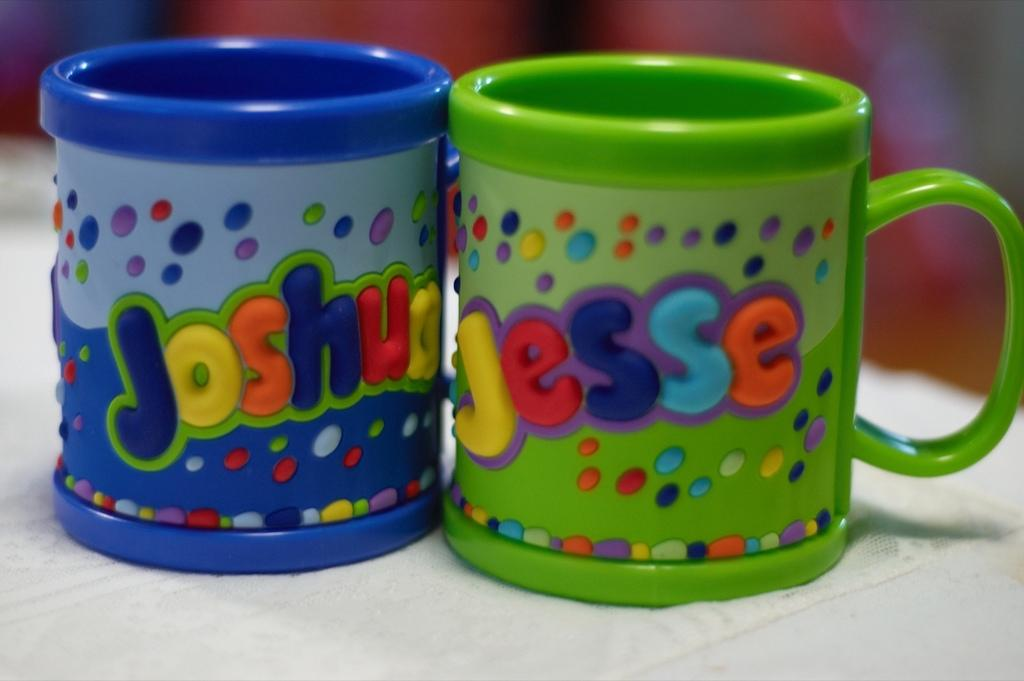<image>
Share a concise interpretation of the image provided. Blue cup that says Joshua next to a green cup that says Jesse. 